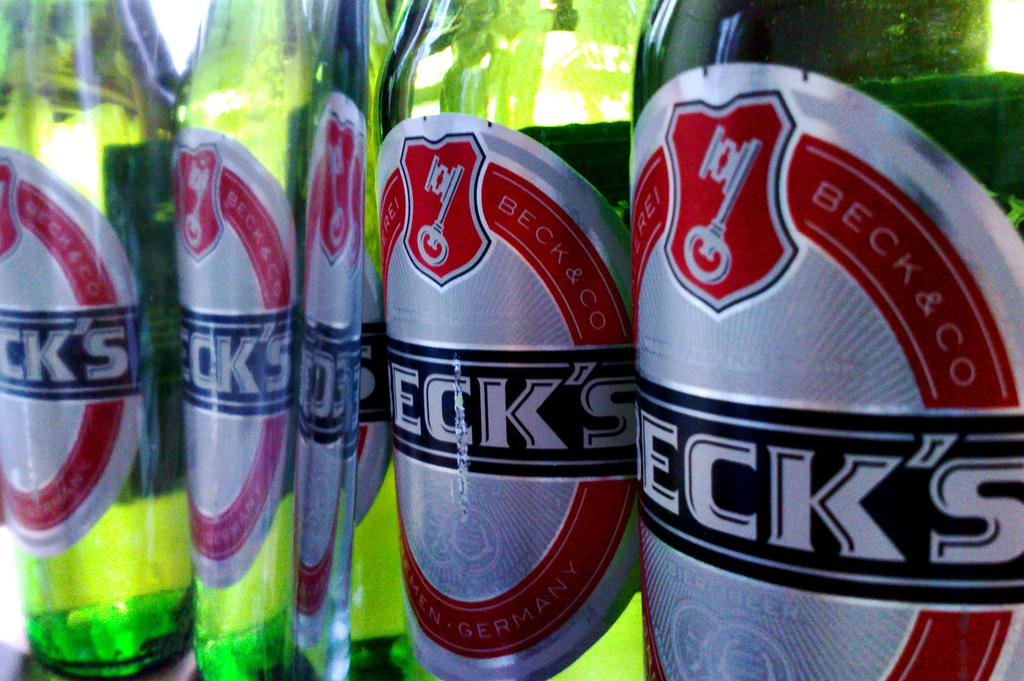What type of beverage containers are present in the image? There are beer bottles in the image. What color are the beer bottles? The beer bottles are green in color. Are there any distinguishing features on the beer bottles? Yes, there is a label attached to the beer bottles. What is the purpose of the frame in the image? There is no frame present in the image; it only features beer bottles with a label. 